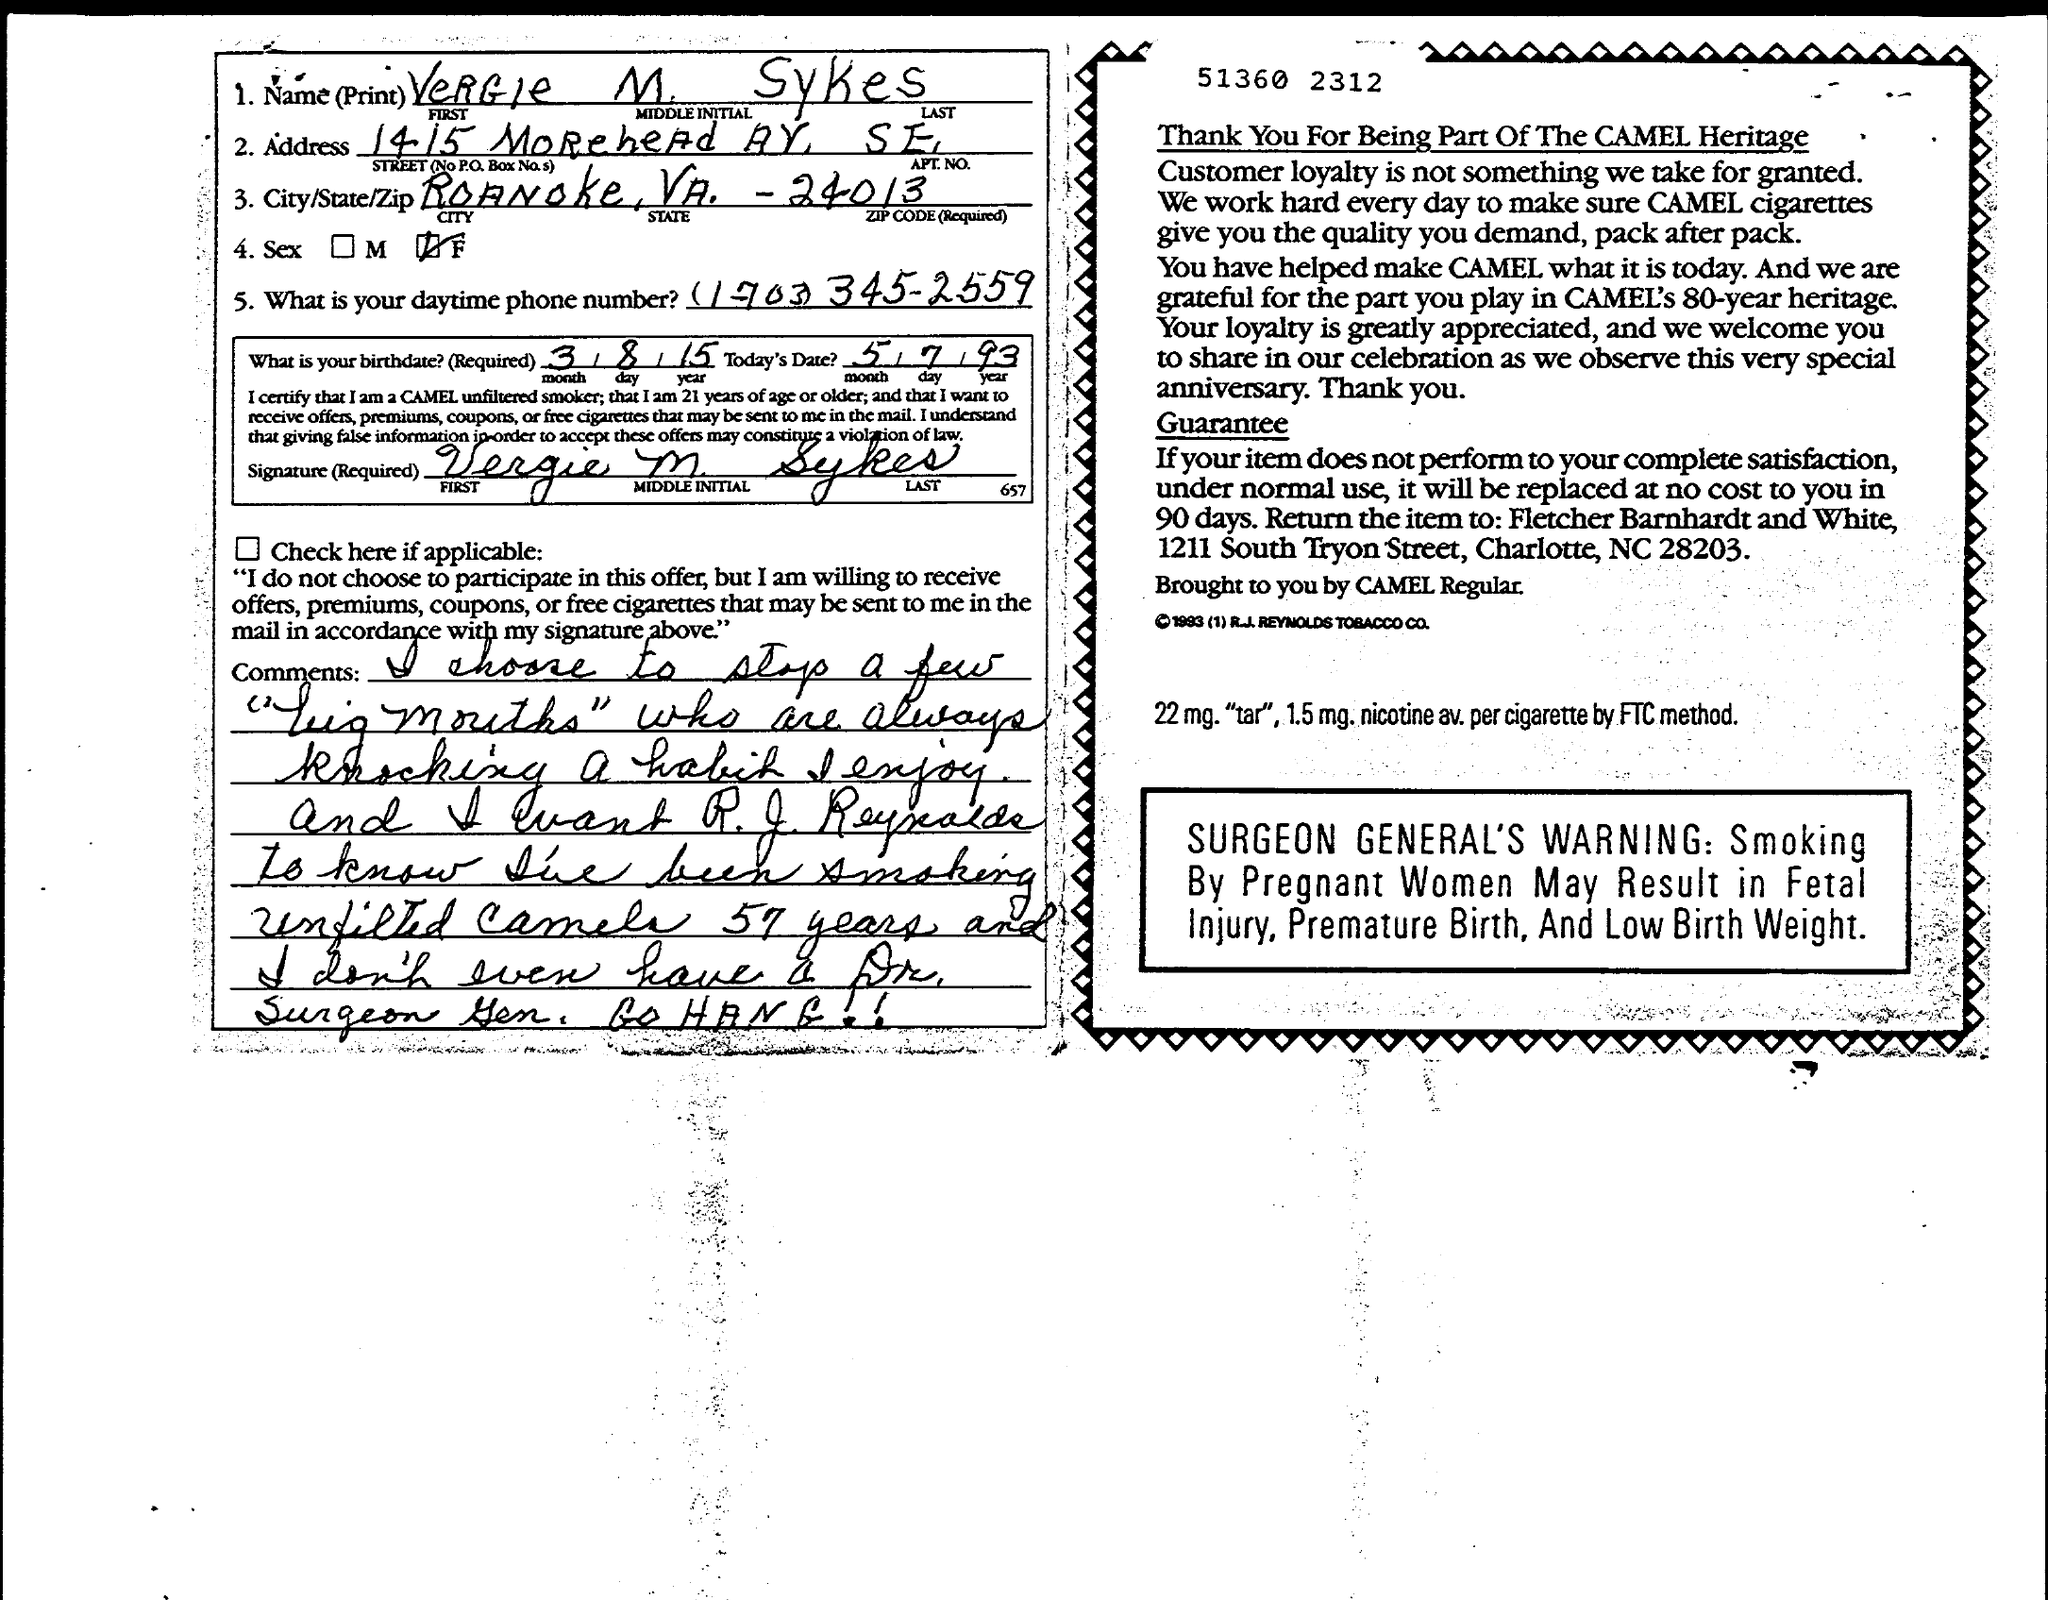Mention a couple of crucial points in this snapshot. Vergie M Sykes is the name mentioned. The given text is a query in the form of a question that asks for information about a city, state, and ZIP code. The city is Roanoke, the state is Virginia, and the ZIP code is -24013. 